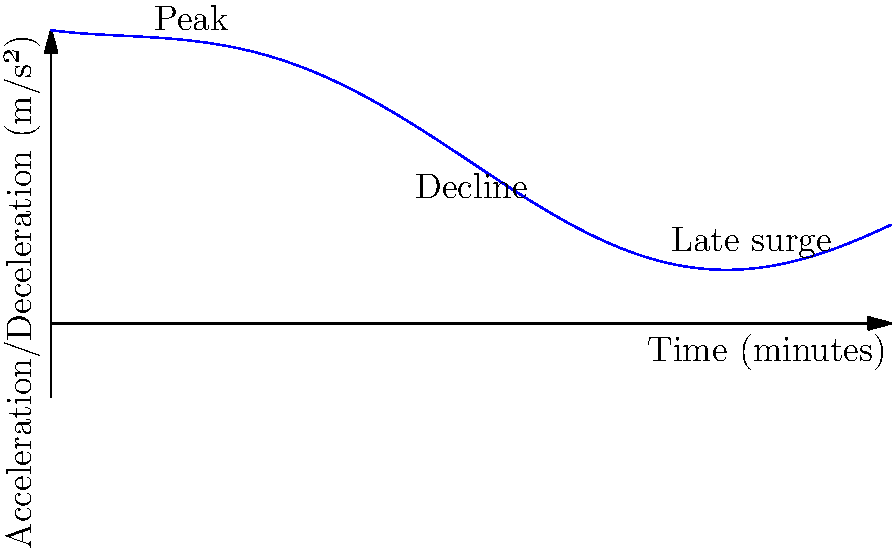The graph shows the acceleration and deceleration patterns of Jürgen Sparwasser, the East German footballer famous for scoring the winning goal against West Germany in the 1974 World Cup, during a typical 90-minute match. At which point in the match does Sparwasser's ability to accelerate and decelerate reach its maximum, and what factors unique to East German football at that time might have contributed to this pattern? To answer this question, we need to analyze the graph and consider the historical context of East German football:

1. Examine the graph: The y-axis represents acceleration/deceleration in m/s², while the x-axis shows the match duration in minutes.

2. Identify the peak: The highest point on the graph occurs around the 15-minute mark, indicating Sparwasser's maximum acceleration/deceleration capability.

3. Consider the pattern: The graph shows a rapid increase in the first 15 minutes, followed by a gradual decline, and a slight resurgence towards the end of the match.

4. Historical context: East German football in the 1970s was characterized by:
   a) Rigorous physical training regimes
   b) Emphasis on explosive starts to gain early advantages
   c) Limited substitutions, requiring players to manage their energy throughout the match

5. Factors contributing to the pattern:
   a) Intense warm-up and preparation before the match, leading to peak performance early on
   b) The "Spartakiade" system of youth sports in East Germany, which emphasized early physical development
   c) Tactical approach favoring strong starts to demoralize opponents
   d) Limited resources and squad depth, necessitating careful energy management throughout the game

6. The late surge could be attributed to:
   a) Mental toughness instilled by the East German training system
   b) The need to push for results in the final minutes, especially in politically charged matches

Given these factors, Sparwasser's peak performance at the 15-minute mark aligns with the East German football philosophy of the time, emphasizing explosive starts and careful energy management throughout the match.
Answer: 15 minutes 